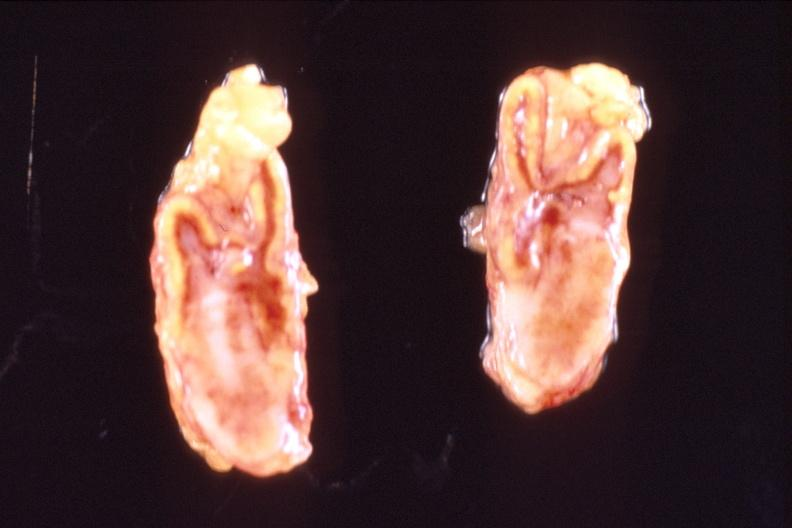where does this belong to?
Answer the question using a single word or phrase. Endocrine system 